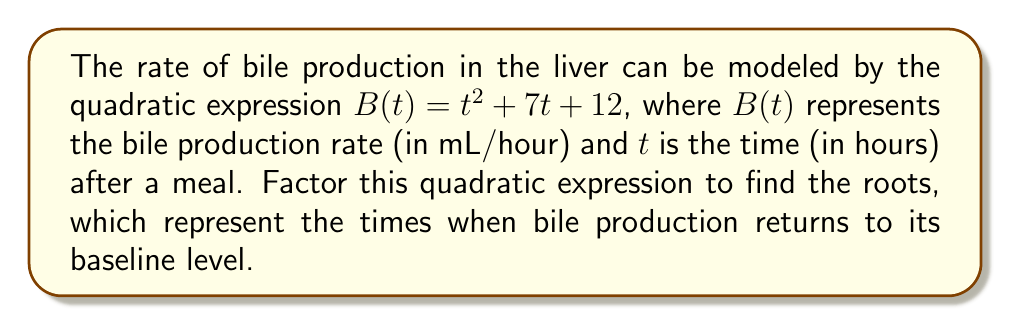Can you solve this math problem? To factor this quadratic expression, we'll follow these steps:

1) The quadratic expression is in the form $at^2 + bt + c$, where $a=1$, $b=7$, and $c=12$.

2) We need to find two numbers that multiply to give $ac = 1 \times 12 = 12$ and add up to $b = 7$.

3) The numbers that satisfy this are 3 and 4, as $3 \times 4 = 12$ and $3 + 4 = 7$.

4) We can rewrite the middle term using these numbers:
   $B(t) = t^2 + 7t + 12 = t^2 + 3t + 4t + 12$

5) Now we can factor by grouping:
   $B(t) = (t^2 + 3t) + (4t + 12)$
   $B(t) = t(t + 3) + 4(t + 3)$
   $B(t) = (t + 3)(t + 4)$

6) The factored form $(t + 3)(t + 4)$ gives us the roots of the equation. The bile production returns to baseline when $B(t) = 0$, which occurs when either $(t + 3) = 0$ or $(t + 4) = 0$.

7) Solving these:
   $t + 3 = 0$ gives $t = -3$
   $t + 4 = 0$ gives $t = -4$

However, since time cannot be negative in this context, these roots do not have a physical meaning for bile production. The quadratic never reaches zero for positive time values, indicating that bile production never exactly returns to the baseline in this model.
Answer: $B(t) = (t + 3)(t + 4)$ 